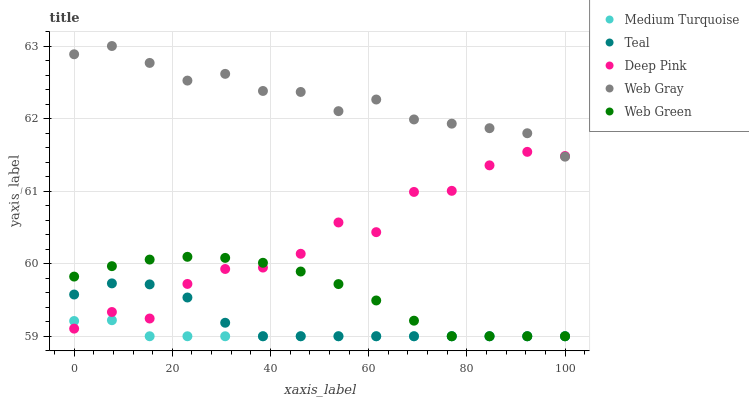Does Medium Turquoise have the minimum area under the curve?
Answer yes or no. Yes. Does Web Gray have the maximum area under the curve?
Answer yes or no. Yes. Does Deep Pink have the minimum area under the curve?
Answer yes or no. No. Does Deep Pink have the maximum area under the curve?
Answer yes or no. No. Is Medium Turquoise the smoothest?
Answer yes or no. Yes. Is Deep Pink the roughest?
Answer yes or no. Yes. Is Web Gray the smoothest?
Answer yes or no. No. Is Web Gray the roughest?
Answer yes or no. No. Does Web Green have the lowest value?
Answer yes or no. Yes. Does Deep Pink have the lowest value?
Answer yes or no. No. Does Web Gray have the highest value?
Answer yes or no. Yes. Does Deep Pink have the highest value?
Answer yes or no. No. Is Web Green less than Web Gray?
Answer yes or no. Yes. Is Web Gray greater than Teal?
Answer yes or no. Yes. Does Web Gray intersect Deep Pink?
Answer yes or no. Yes. Is Web Gray less than Deep Pink?
Answer yes or no. No. Is Web Gray greater than Deep Pink?
Answer yes or no. No. Does Web Green intersect Web Gray?
Answer yes or no. No. 